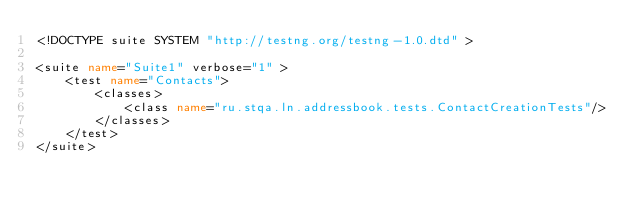Convert code to text. <code><loc_0><loc_0><loc_500><loc_500><_XML_><!DOCTYPE suite SYSTEM "http://testng.org/testng-1.0.dtd" >

<suite name="Suite1" verbose="1" >
    <test name="Contacts">
        <classes>
            <class name="ru.stqa.ln.addressbook.tests.ContactCreationTests"/>
        </classes>
    </test>
</suite>
</code> 